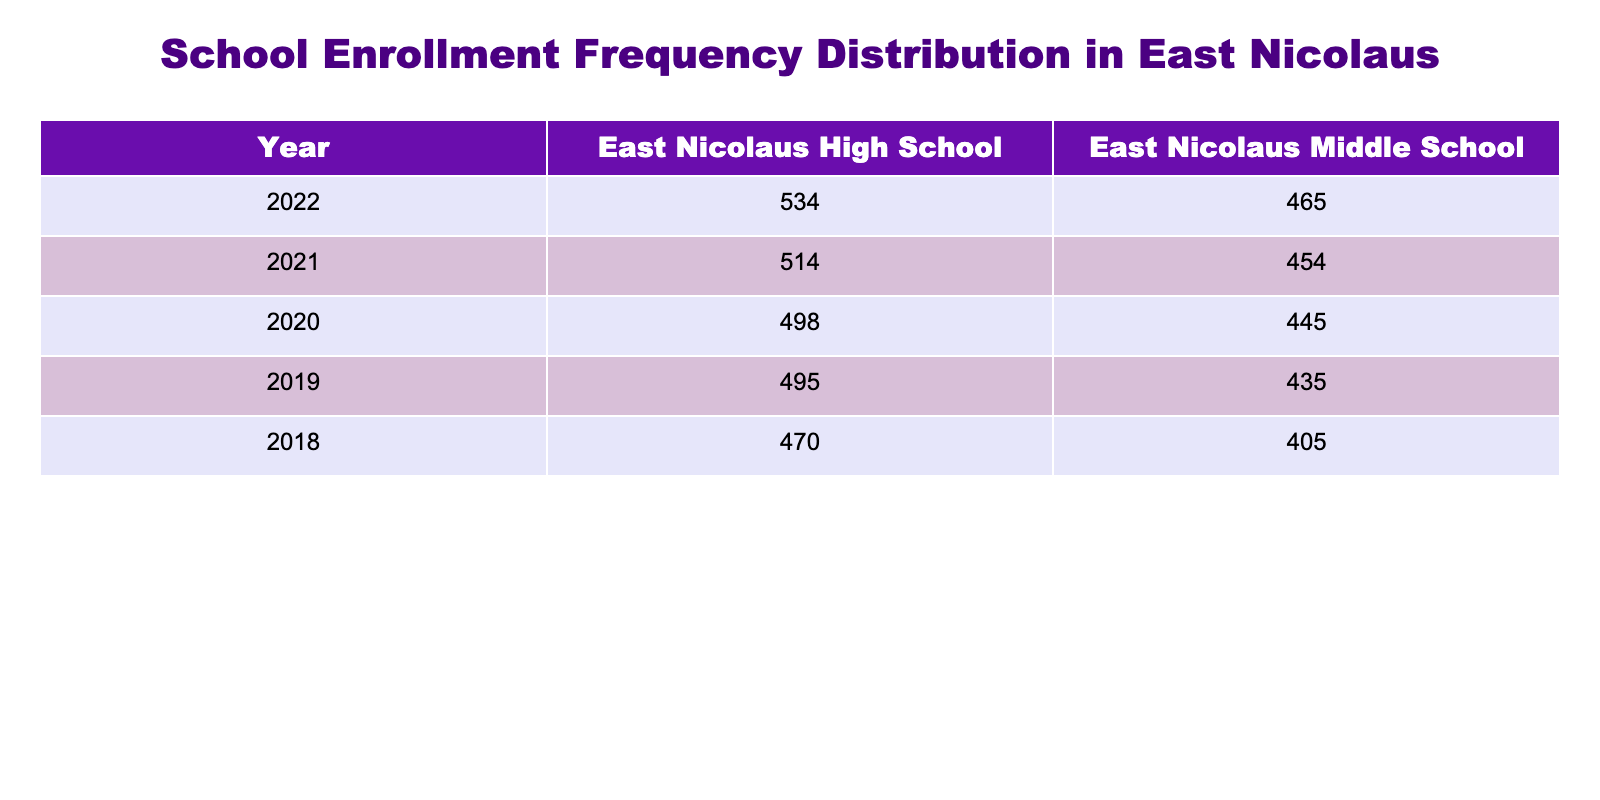What was the enrollment for 7th grade in 2020? In the 2020 row for East Nicolaus Middle School, the enrollment for the 7th grade is listed as 148.
Answer: 148 What is the total enrollment for East Nicolaus High School across all grades in 2019? To find the total enrollment for East Nicolaus High School in 2019, we add the enrollment figures for all grades: 130 (9th) + 120 (10th) + 115 (11th) + 130 (12th) = 495.
Answer: 495 Did the enrollment for 12th grade at East Nicolaus High School increase from 2020 to 2021? In 2020, the enrollment for 12th grade was 133, and in 2021 it increased to 135. Therefore, there was an increase.
Answer: Yes What was the percentage increase in enrollment for 8th grade from 2018 to 2022? The enrollment for 8th grade in 2018 was 140 and in 2022 it was 160. The increase in enrollment is 160 - 140 = 20. The percentage increase is (20 / 140) * 100 = 14.29%.
Answer: 14.29% What was the average enrollment for 9th grade over the five years? The enrollment figures for 9th grade from 2018 to 2022 are: 120, 130, 125, 128, and 135. The total enrollment is 120 + 130 + 125 + 128 + 135 = 638. Dividing by 5 (years) gives an average of 127.6.
Answer: 127.6 What was the highest enrollment recorded for 7th grade? By examining the table, the enrollment figures for 7th grade over the years are: 135 (2018), 145 (2019), 148 (2020), 152 (2021), and 155 (2022). The highest figure is 155 in 2022.
Answer: 155 Was the enrollment for 6th grade higher in 2022 than in 2019? The enrollment for 6th grade in 2022 is 150, while in 2019 it was 140. Since 150 is greater than 140, 6th grade enrollment was higher in 2022.
Answer: Yes What is the total enrollment across all grades at East Nicolaus Middle School in 2021? To find the total enrollment for East Nicolaus Middle School in 2021, we sum the figures for all grades: 144 (6th) + 152 (7th) + 158 (8th) = 454.
Answer: 454 How much did the enrollment for 11th grade at East Nicolaus High School decrease from 2018 to 2020? The enrollment for 11th grade in 2018 was 110 and in 2020 it was 118, indicating an increase rather than a decrease.
Answer: 0 